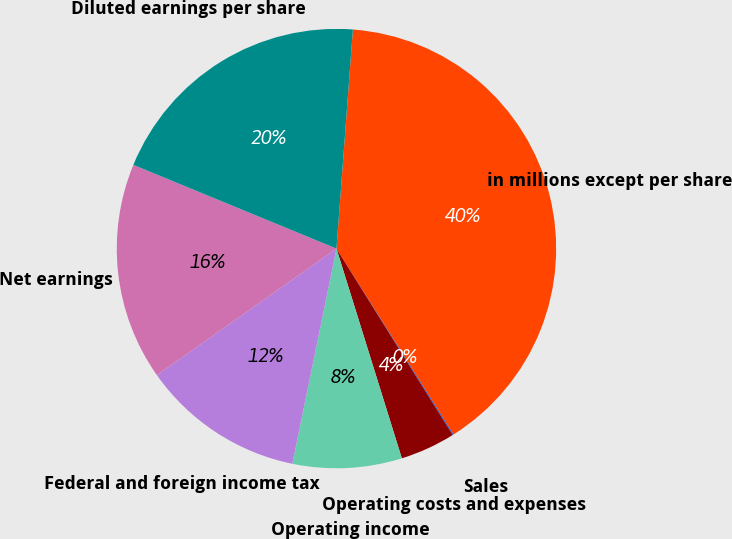Convert chart. <chart><loc_0><loc_0><loc_500><loc_500><pie_chart><fcel>in millions except per share<fcel>Sales<fcel>Operating costs and expenses<fcel>Operating income<fcel>Federal and foreign income tax<fcel>Net earnings<fcel>Diluted earnings per share<nl><fcel>39.86%<fcel>0.08%<fcel>4.06%<fcel>8.03%<fcel>12.01%<fcel>15.99%<fcel>19.97%<nl></chart> 